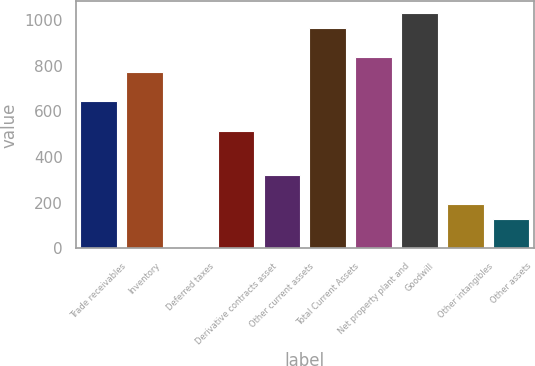<chart> <loc_0><loc_0><loc_500><loc_500><bar_chart><fcel>Trade receivables<fcel>Inventory<fcel>Deferred taxes<fcel>Derivative contracts asset<fcel>Other current assets<fcel>Total Current Assets<fcel>Net property plant and<fcel>Goodwill<fcel>Other intangibles<fcel>Other assets<nl><fcel>643.9<fcel>772.52<fcel>0.8<fcel>515.28<fcel>322.35<fcel>965.45<fcel>836.83<fcel>1029.76<fcel>193.73<fcel>129.42<nl></chart> 